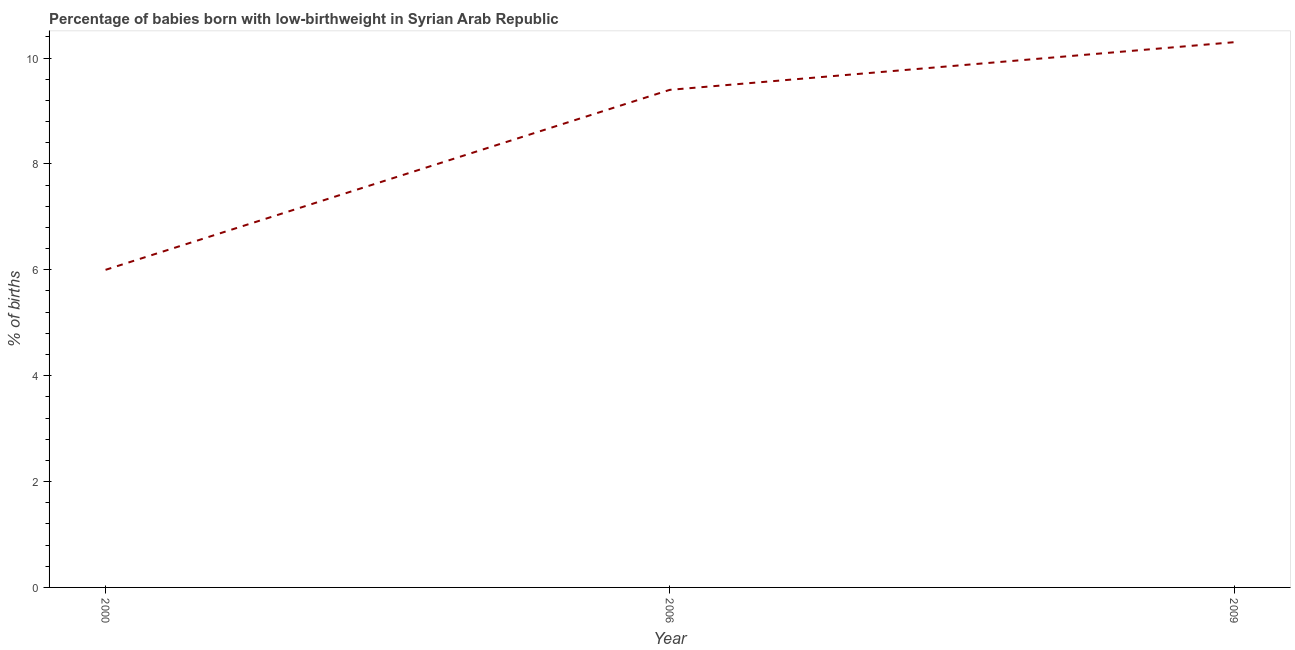What is the percentage of babies who were born with low-birthweight in 2006?
Your response must be concise. 9.4. In which year was the percentage of babies who were born with low-birthweight maximum?
Your answer should be compact. 2009. What is the sum of the percentage of babies who were born with low-birthweight?
Offer a very short reply. 25.7. What is the difference between the percentage of babies who were born with low-birthweight in 2000 and 2009?
Ensure brevity in your answer.  -4.3. What is the average percentage of babies who were born with low-birthweight per year?
Provide a short and direct response. 8.57. What is the median percentage of babies who were born with low-birthweight?
Ensure brevity in your answer.  9.4. What is the ratio of the percentage of babies who were born with low-birthweight in 2006 to that in 2009?
Provide a succinct answer. 0.91. Is the percentage of babies who were born with low-birthweight in 2006 less than that in 2009?
Your response must be concise. Yes. What is the difference between the highest and the second highest percentage of babies who were born with low-birthweight?
Your response must be concise. 0.9. Is the sum of the percentage of babies who were born with low-birthweight in 2000 and 2009 greater than the maximum percentage of babies who were born with low-birthweight across all years?
Keep it short and to the point. Yes. What is the difference between the highest and the lowest percentage of babies who were born with low-birthweight?
Offer a terse response. 4.3. In how many years, is the percentage of babies who were born with low-birthweight greater than the average percentage of babies who were born with low-birthweight taken over all years?
Make the answer very short. 2. What is the difference between two consecutive major ticks on the Y-axis?
Make the answer very short. 2. Does the graph contain any zero values?
Make the answer very short. No. Does the graph contain grids?
Ensure brevity in your answer.  No. What is the title of the graph?
Make the answer very short. Percentage of babies born with low-birthweight in Syrian Arab Republic. What is the label or title of the Y-axis?
Offer a very short reply. % of births. What is the % of births in 2000?
Your answer should be compact. 6. What is the difference between the % of births in 2000 and 2006?
Provide a short and direct response. -3.4. What is the difference between the % of births in 2000 and 2009?
Provide a short and direct response. -4.3. What is the ratio of the % of births in 2000 to that in 2006?
Give a very brief answer. 0.64. What is the ratio of the % of births in 2000 to that in 2009?
Make the answer very short. 0.58. What is the ratio of the % of births in 2006 to that in 2009?
Your response must be concise. 0.91. 